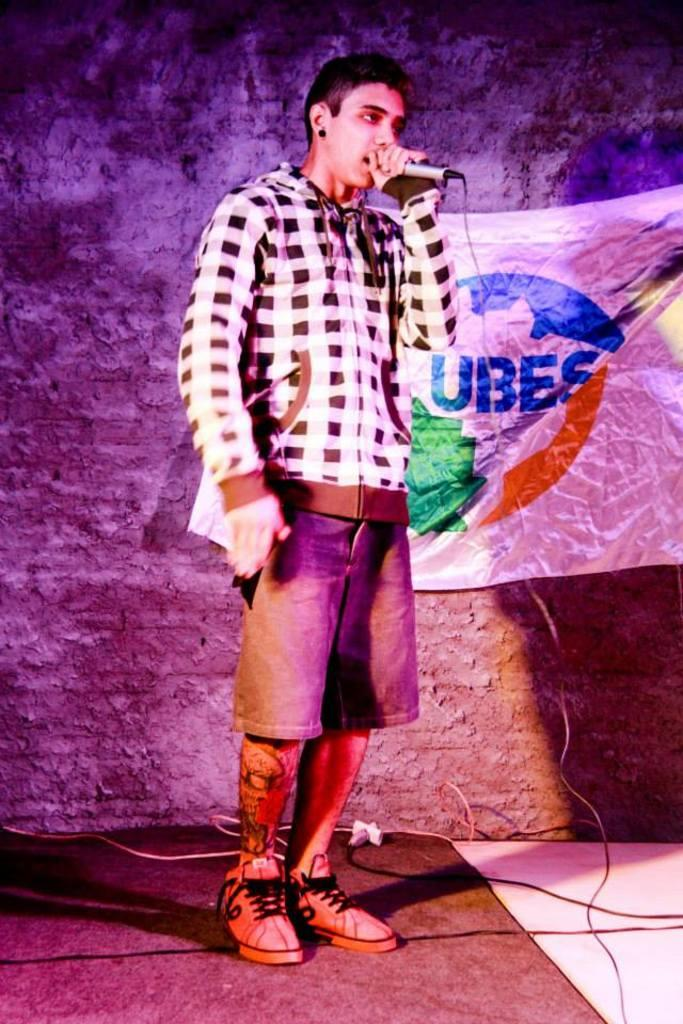What is the main subject of the image? There is a man standing in the center of the image. What is the man holding in the image? The man is holding a mic. What can be seen in the background of the image? There is a board and a wall in the background of the image. What else is present at the bottom of the image? Wires are present at the bottom of the image. What type of fruit is being offered by the fairies in the image? There are no fairies or fruit present in the image. Can you tell me what card game the man is playing in the image? There is no card game or card present in the image; the man is holding a mic. 